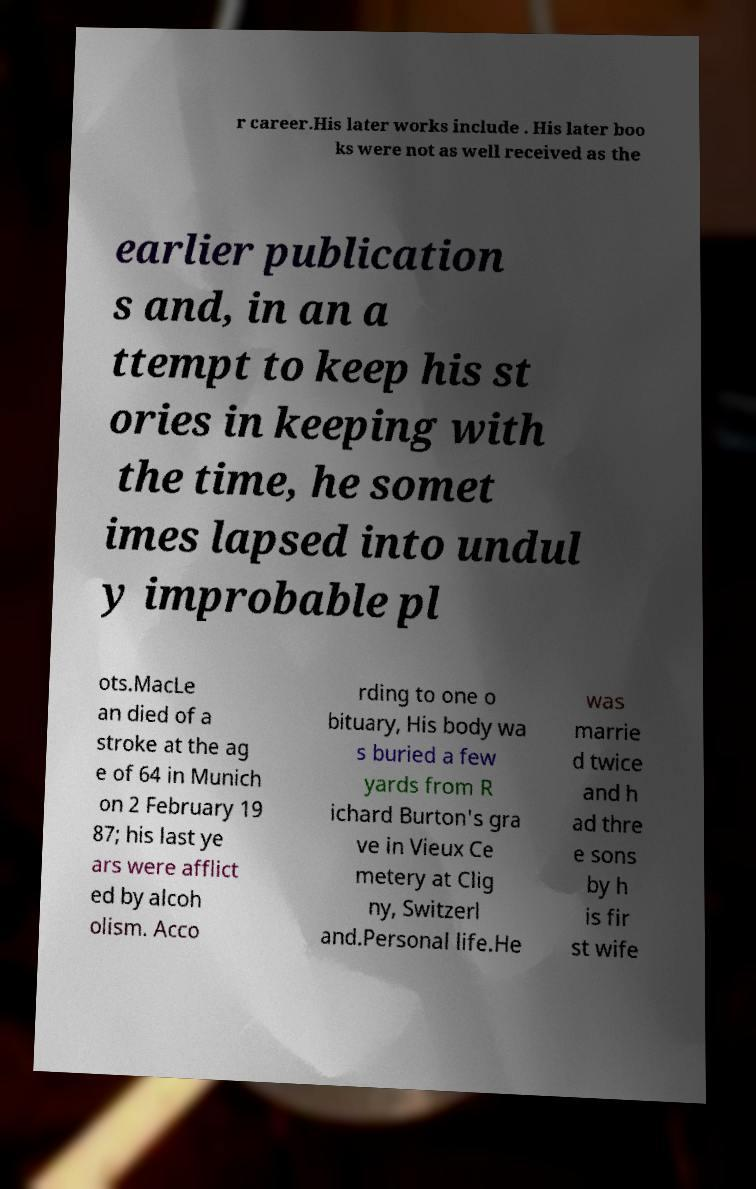Could you extract and type out the text from this image? r career.His later works include . His later boo ks were not as well received as the earlier publication s and, in an a ttempt to keep his st ories in keeping with the time, he somet imes lapsed into undul y improbable pl ots.MacLe an died of a stroke at the ag e of 64 in Munich on 2 February 19 87; his last ye ars were afflict ed by alcoh olism. Acco rding to one o bituary, His body wa s buried a few yards from R ichard Burton's gra ve in Vieux Ce metery at Clig ny, Switzerl and.Personal life.He was marrie d twice and h ad thre e sons by h is fir st wife 